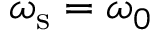<formula> <loc_0><loc_0><loc_500><loc_500>\omega _ { s } = \omega _ { 0 }</formula> 